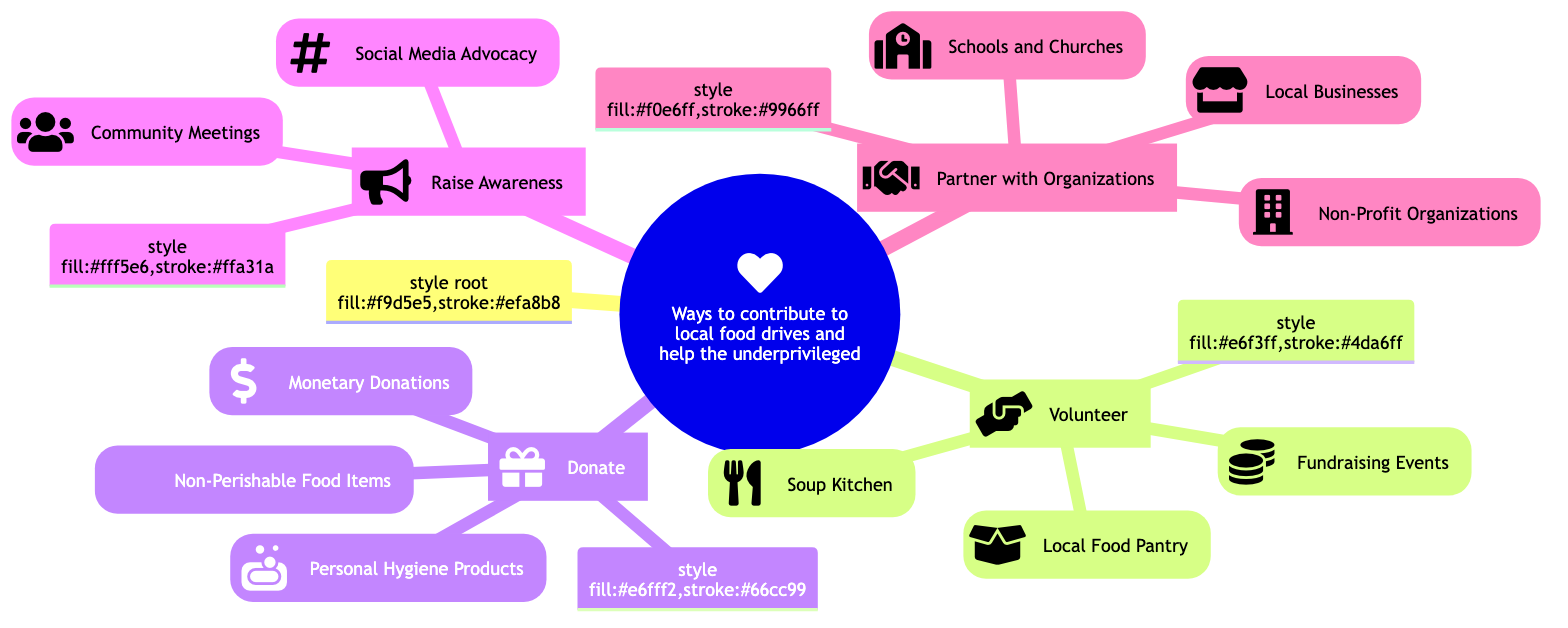What are the four main ways to contribute? The diagram lists four main subtopics under the main topic: Volunteer, Donate, Raise Awareness, and Partner with Organizations.
Answer: Volunteer, Donate, Raise Awareness, Partner with Organizations How many details are listed under the Donate subtopic? Under the Donate subtopic, there are three detailed items: Non-Perishable Food Items, Monetary Donations, and Personal Hygiene Products.
Answer: 3 What is one activity you can do at a Soup Kitchen? The diagram specifies that at a Soup Kitchen, you can assist in preparing and serving meals.
Answer: Assist in preparing and serving meals Which subtopic includes social media advocacy? The Raise Awareness subtopic includes the detail of Social Media Advocacy, which is a method of sharing information on platforms like Facebook, Instagram, and Twitter.
Answer: Raise Awareness What type of organizations can partner with local food drives? The diagram indicates that local businesses, non-profit organizations, and schools and churches can partner with local food drives.
Answer: Local businesses, non-profit organizations, schools and churches Which action involves organizing food collection campaigns? Engaging local stores in food collection campaigns is a detail under the Partner with Organizations subtopic.
Answer: Engaging local stores How many activities are listed under the Volunteer category? There are three activities listed under the Volunteer category: Local Food Pantry, Soup Kitchen, and Fundraising Events.
Answer: 3 What type of donations can help buy food in bulk? The diagram mentions Monetary Donations as a contribution type that provides financial support to purchase food in bulk.
Answer: Monetary Donations What is the purpose of community meetings according to the diagram? Community Meetings, as listed under the Raise Awareness subtopic, aim to discuss food insecurity issues at local group gatherings.
Answer: Discuss food insecurity issues 